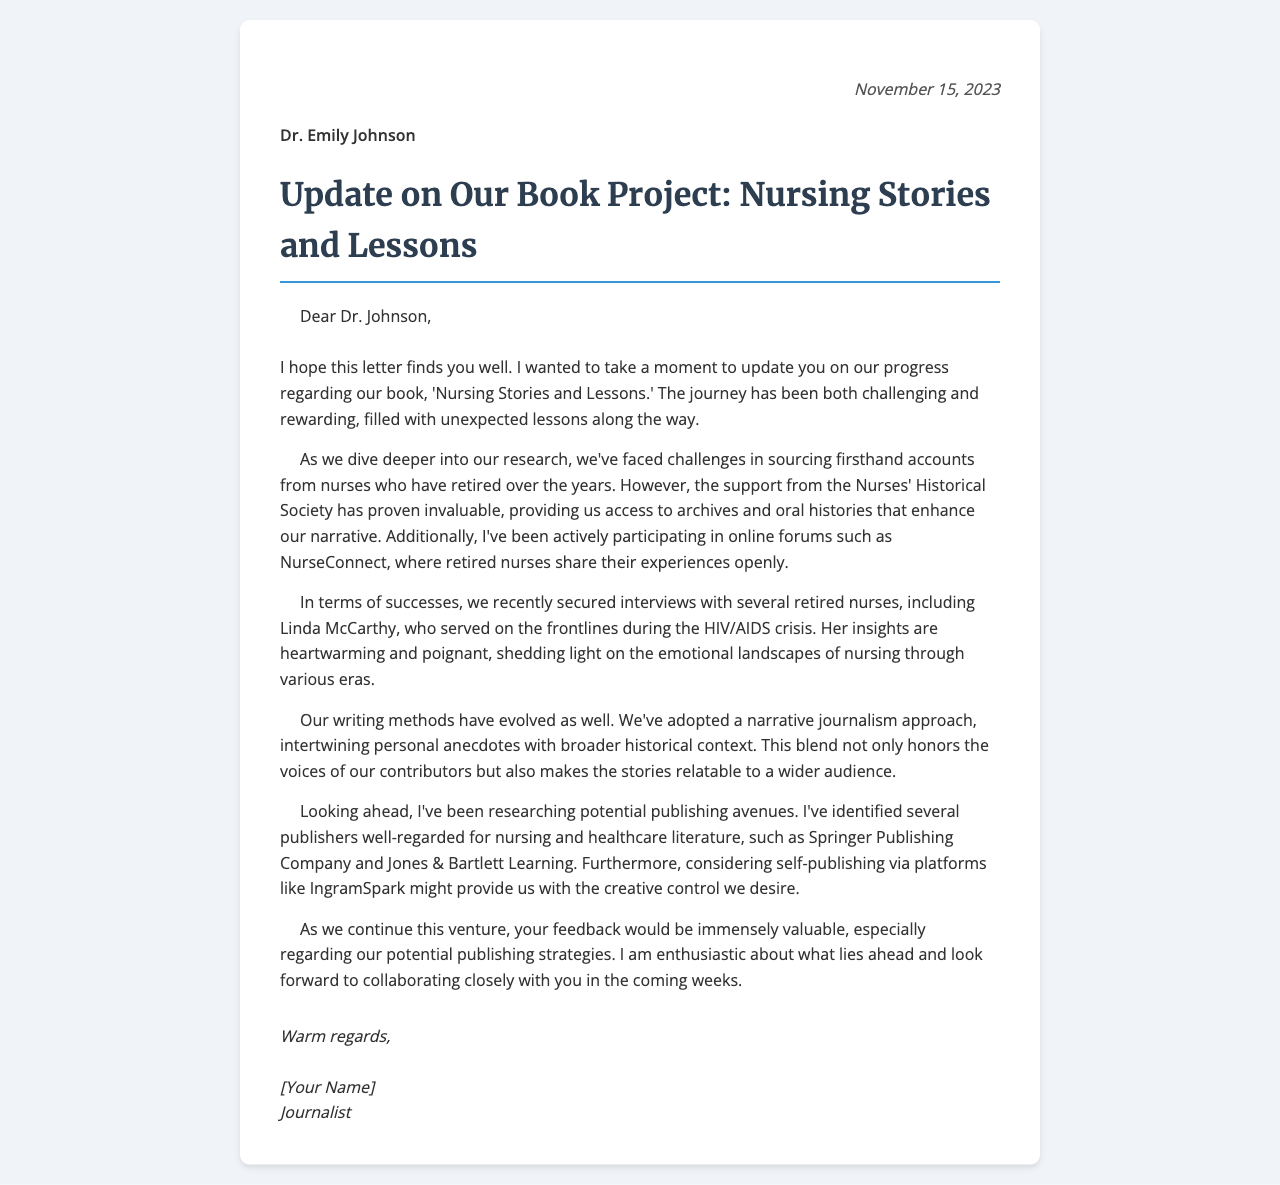What is the date of the letter? The date mentioned at the top of the letter indicates when it was written, which is November 15, 2023.
Answer: November 15, 2023 Who is the recipient of the letter? The letter is addressed to Dr. Emily Johnson, indicating she is the intended recipient.
Answer: Dr. Emily Johnson What is the title of the book being written? The title of the book mentioned in the letter is 'Nursing Stories and Lessons,' which reflects the content focus.
Answer: Nursing Stories and Lessons Which nursing organization provided support? The letter states that the Nurses' Historical Society has been instrumental in providing resources and support for research.
Answer: Nurses' Historical Society Which retired nurse was recently interviewed? Linda McCarthy is named in the letter as one of the interviewed retired nurses, highlighting her significant experiences.
Answer: Linda McCarthy What research method has been adopted for writing? The letter mentions that a narrative journalism approach has been adopted to blend personal anecdotes with historical context.
Answer: Narrative journalism approach What are two potential publishing avenues mentioned? The letter lists Springer Publishing Company and Jones & Bartlett Learning as traditional publishing options. Additionally, it mentions self-publishing with IngramSpark.
Answer: Springer Publishing Company, Jones & Bartlett Learning What type of challenges are discussed in the letter? The letter discusses challenges in sourcing firsthand accounts, indicating difficulties in collecting narratives from retired nurses.
Answer: Sourcing firsthand accounts What feedback is being sought from Dr. Johnson? The letter specifically mentions seeking feedback regarding potential publishing strategies to enhance their decision-making process.
Answer: Publishing strategies 